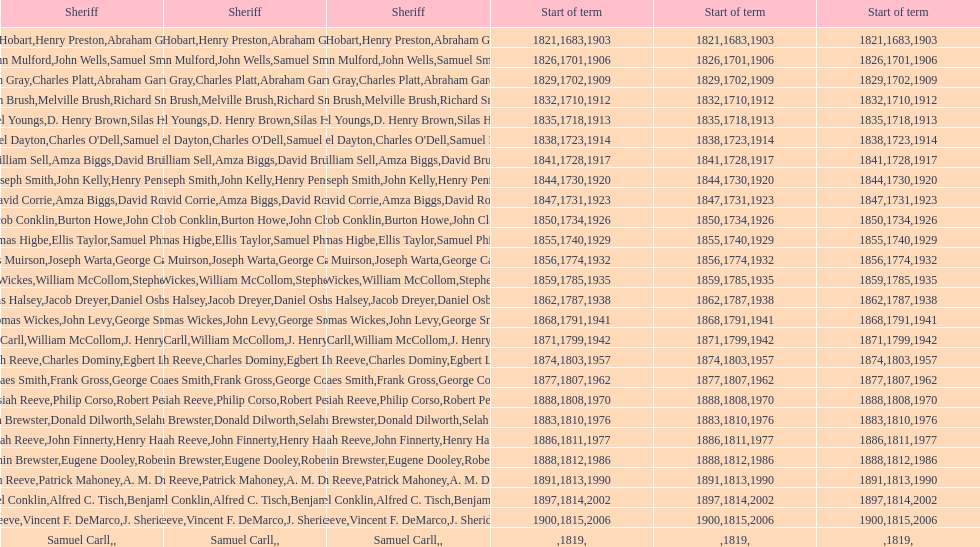How many sheriff's have the last name biggs? 1. 